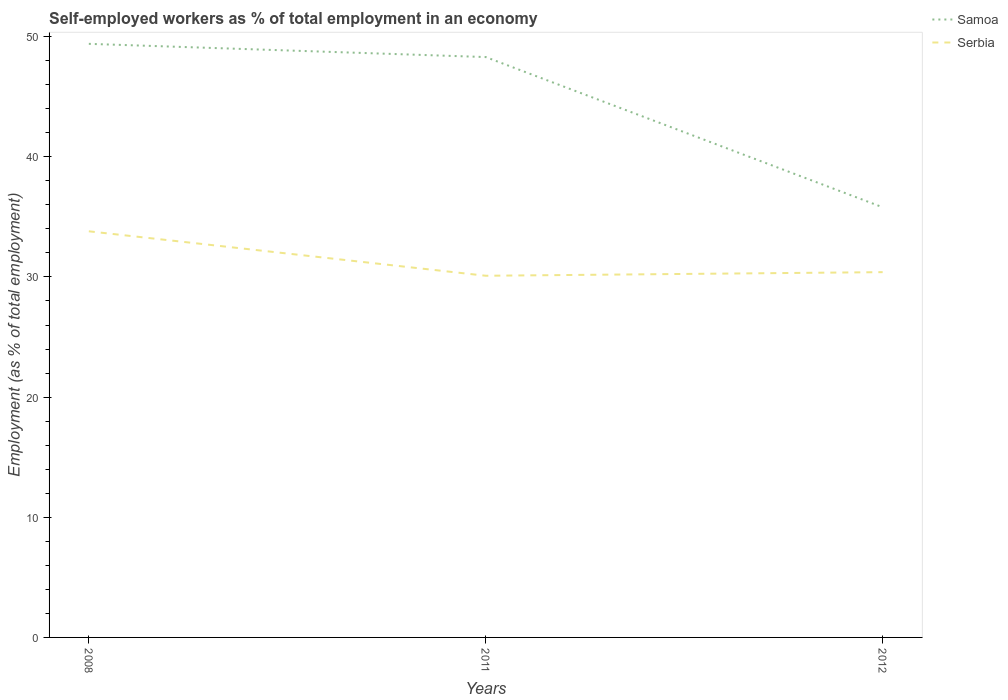How many different coloured lines are there?
Make the answer very short. 2. Across all years, what is the maximum percentage of self-employed workers in Serbia?
Your response must be concise. 30.1. What is the total percentage of self-employed workers in Serbia in the graph?
Give a very brief answer. -0.3. What is the difference between the highest and the second highest percentage of self-employed workers in Samoa?
Your answer should be very brief. 13.6. Is the percentage of self-employed workers in Serbia strictly greater than the percentage of self-employed workers in Samoa over the years?
Keep it short and to the point. Yes. How many years are there in the graph?
Make the answer very short. 3. What is the difference between two consecutive major ticks on the Y-axis?
Your answer should be very brief. 10. Are the values on the major ticks of Y-axis written in scientific E-notation?
Make the answer very short. No. Where does the legend appear in the graph?
Your answer should be very brief. Top right. How are the legend labels stacked?
Ensure brevity in your answer.  Vertical. What is the title of the graph?
Offer a terse response. Self-employed workers as % of total employment in an economy. What is the label or title of the X-axis?
Your answer should be very brief. Years. What is the label or title of the Y-axis?
Give a very brief answer. Employment (as % of total employment). What is the Employment (as % of total employment) of Samoa in 2008?
Your answer should be compact. 49.4. What is the Employment (as % of total employment) in Serbia in 2008?
Your answer should be very brief. 33.8. What is the Employment (as % of total employment) of Samoa in 2011?
Your answer should be compact. 48.3. What is the Employment (as % of total employment) of Serbia in 2011?
Your answer should be very brief. 30.1. What is the Employment (as % of total employment) of Samoa in 2012?
Provide a short and direct response. 35.8. What is the Employment (as % of total employment) in Serbia in 2012?
Your answer should be very brief. 30.4. Across all years, what is the maximum Employment (as % of total employment) in Samoa?
Your response must be concise. 49.4. Across all years, what is the maximum Employment (as % of total employment) in Serbia?
Keep it short and to the point. 33.8. Across all years, what is the minimum Employment (as % of total employment) in Samoa?
Provide a succinct answer. 35.8. Across all years, what is the minimum Employment (as % of total employment) of Serbia?
Provide a short and direct response. 30.1. What is the total Employment (as % of total employment) in Samoa in the graph?
Ensure brevity in your answer.  133.5. What is the total Employment (as % of total employment) in Serbia in the graph?
Provide a succinct answer. 94.3. What is the difference between the Employment (as % of total employment) in Serbia in 2008 and that in 2011?
Offer a very short reply. 3.7. What is the difference between the Employment (as % of total employment) in Serbia in 2008 and that in 2012?
Make the answer very short. 3.4. What is the difference between the Employment (as % of total employment) of Samoa in 2011 and that in 2012?
Provide a short and direct response. 12.5. What is the difference between the Employment (as % of total employment) in Serbia in 2011 and that in 2012?
Give a very brief answer. -0.3. What is the difference between the Employment (as % of total employment) in Samoa in 2008 and the Employment (as % of total employment) in Serbia in 2011?
Offer a terse response. 19.3. What is the difference between the Employment (as % of total employment) of Samoa in 2008 and the Employment (as % of total employment) of Serbia in 2012?
Offer a very short reply. 19. What is the average Employment (as % of total employment) in Samoa per year?
Your answer should be compact. 44.5. What is the average Employment (as % of total employment) of Serbia per year?
Keep it short and to the point. 31.43. In the year 2008, what is the difference between the Employment (as % of total employment) in Samoa and Employment (as % of total employment) in Serbia?
Provide a succinct answer. 15.6. In the year 2011, what is the difference between the Employment (as % of total employment) in Samoa and Employment (as % of total employment) in Serbia?
Offer a terse response. 18.2. In the year 2012, what is the difference between the Employment (as % of total employment) in Samoa and Employment (as % of total employment) in Serbia?
Make the answer very short. 5.4. What is the ratio of the Employment (as % of total employment) in Samoa in 2008 to that in 2011?
Your answer should be compact. 1.02. What is the ratio of the Employment (as % of total employment) of Serbia in 2008 to that in 2011?
Your response must be concise. 1.12. What is the ratio of the Employment (as % of total employment) in Samoa in 2008 to that in 2012?
Provide a succinct answer. 1.38. What is the ratio of the Employment (as % of total employment) in Serbia in 2008 to that in 2012?
Your response must be concise. 1.11. What is the ratio of the Employment (as % of total employment) of Samoa in 2011 to that in 2012?
Your response must be concise. 1.35. What is the difference between the highest and the second highest Employment (as % of total employment) of Samoa?
Provide a succinct answer. 1.1. What is the difference between the highest and the second highest Employment (as % of total employment) of Serbia?
Offer a very short reply. 3.4. 